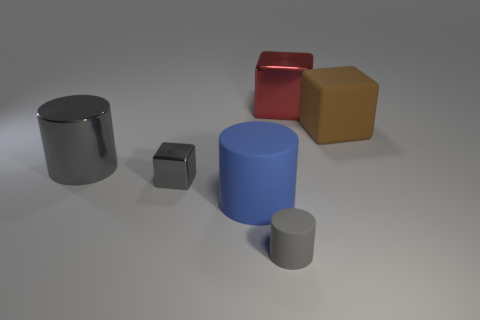Subtract 1 blocks. How many blocks are left? 2 Add 3 big rubber things. How many objects exist? 9 Subtract 0 brown spheres. How many objects are left? 6 Subtract all red cubes. Subtract all small gray matte cylinders. How many objects are left? 4 Add 3 small rubber cylinders. How many small rubber cylinders are left? 4 Add 4 blue matte cylinders. How many blue matte cylinders exist? 5 